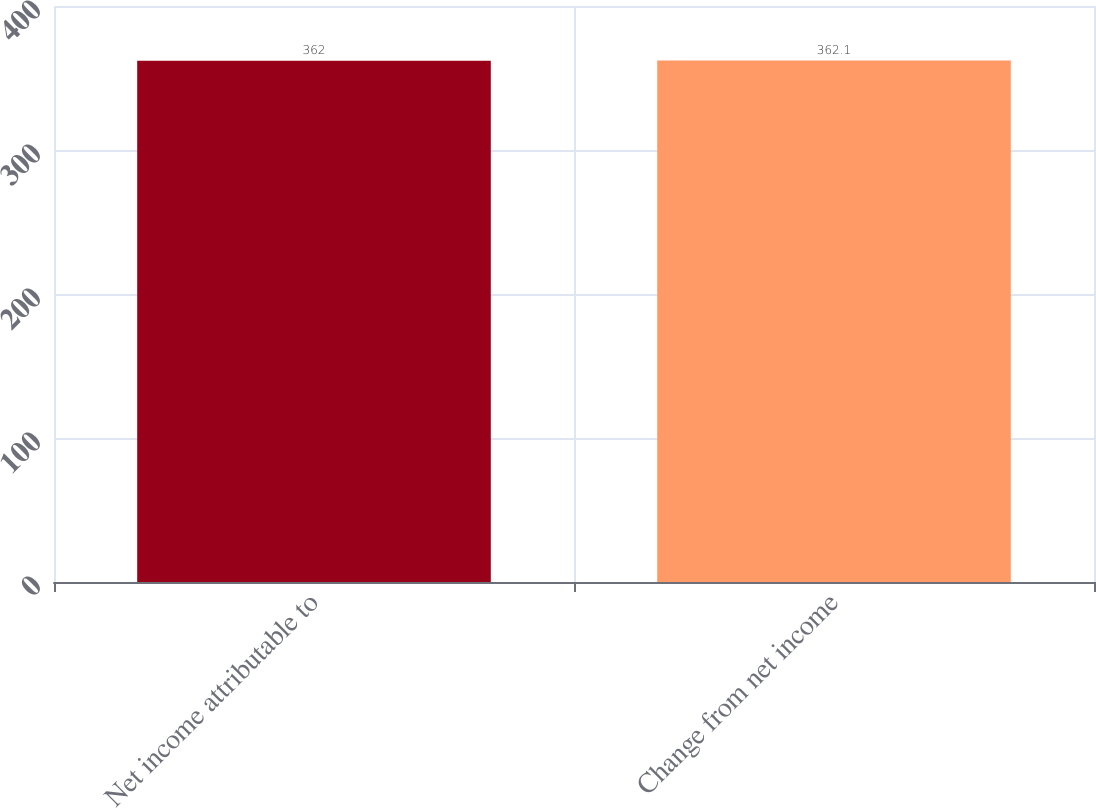<chart> <loc_0><loc_0><loc_500><loc_500><bar_chart><fcel>Net income attributable to<fcel>Change from net income<nl><fcel>362<fcel>362.1<nl></chart> 